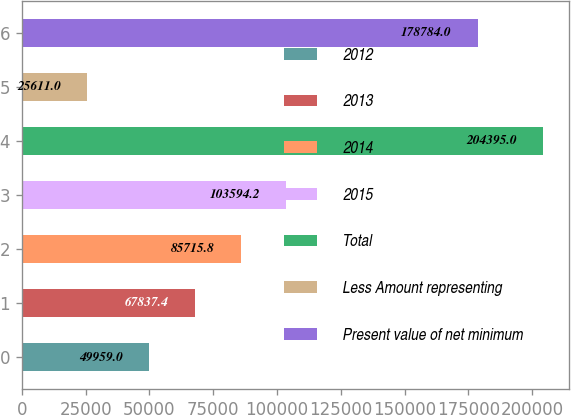Convert chart. <chart><loc_0><loc_0><loc_500><loc_500><bar_chart><fcel>2012<fcel>2013<fcel>2014<fcel>2015<fcel>Total<fcel>Less Amount representing<fcel>Present value of net minimum<nl><fcel>49959<fcel>67837.4<fcel>85715.8<fcel>103594<fcel>204395<fcel>25611<fcel>178784<nl></chart> 